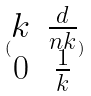<formula> <loc_0><loc_0><loc_500><loc_500>( \begin{matrix} k & \frac { d } { n k } \\ 0 & \frac { 1 } { k } \end{matrix} )</formula> 